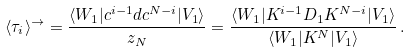Convert formula to latex. <formula><loc_0><loc_0><loc_500><loc_500>\langle \tau _ { i } \rangle ^ { \rightarrow } = \frac { \langle W _ { 1 } | c ^ { i - 1 } d c ^ { N - i } | V _ { 1 } \rangle } { z _ { N } } = \frac { \langle W _ { 1 } | K ^ { i - 1 } D _ { 1 } K ^ { N - i } | V _ { 1 } \rangle } { \langle W _ { 1 } | K ^ { N } | V _ { 1 } \rangle } \, .</formula> 